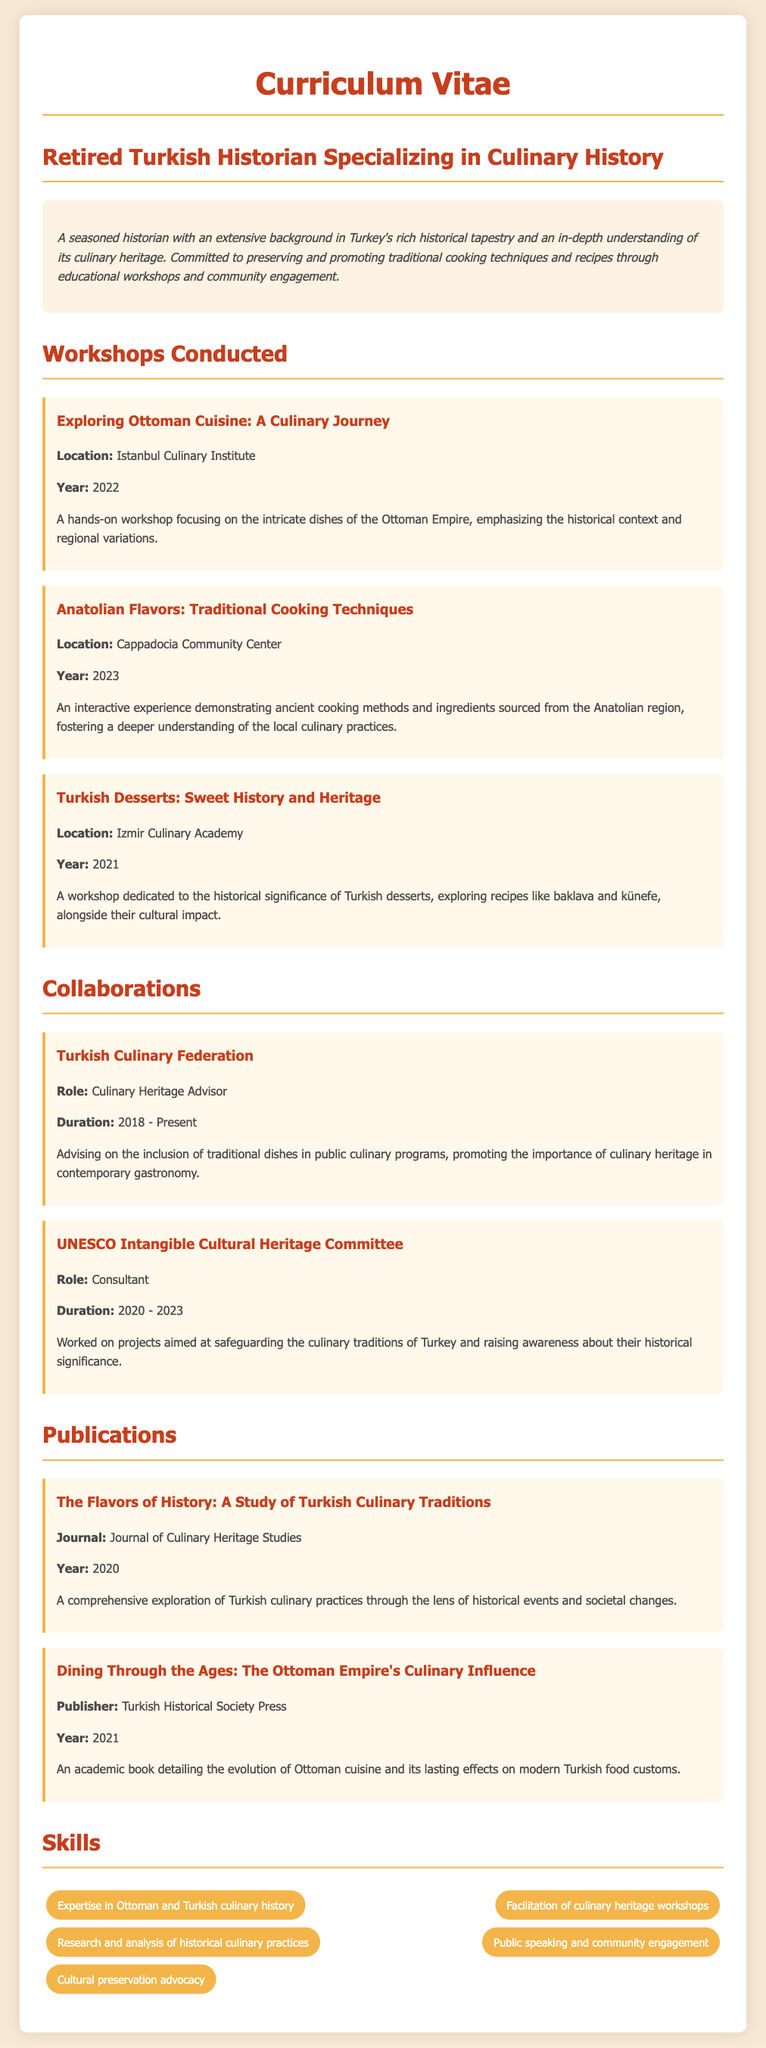What is the title of the first workshop conducted? The question asks for the specific title of the first workshop listed in the document.
Answer: Exploring Ottoman Cuisine: A Culinary Journey Where was the workshop on Turkish Desserts held? This question requires identifying the location of a specific workshop mentioned in the document.
Answer: Izmir Culinary Academy In what year was the workshop on Anatolian Flavors conducted? The question seeks to find out the specific year related to the Anatolian Flavors workshop.
Answer: 2023 What role did the individual hold in the Turkish Culinary Federation? This question asks for a specific role mentioned under the collaborations section of the CV.
Answer: Culinary Heritage Advisor How long did the consultancy with UNESCO last? The question requires calculating the duration from the information provided about the collaboration with UNESCO.
Answer: 3 years Which publication explores Turkish culinary practices in relation to historical events? This question seeks to identify a specific publication that focuses on culinary practices within a historical context.
Answer: The Flavors of History: A Study of Turkish Culinary Traditions What is one of the skills listed in the CV? This question requests any specific skill mentioned in the skills section of the document.
Answer: Expertise in Ottoman and Turkish culinary history What is the primary focus of the culinary workshops conducted? The question requires synthesizing information from the workshops' descriptions to identify their common theme.
Answer: Traditional cooking techniques and recipes 